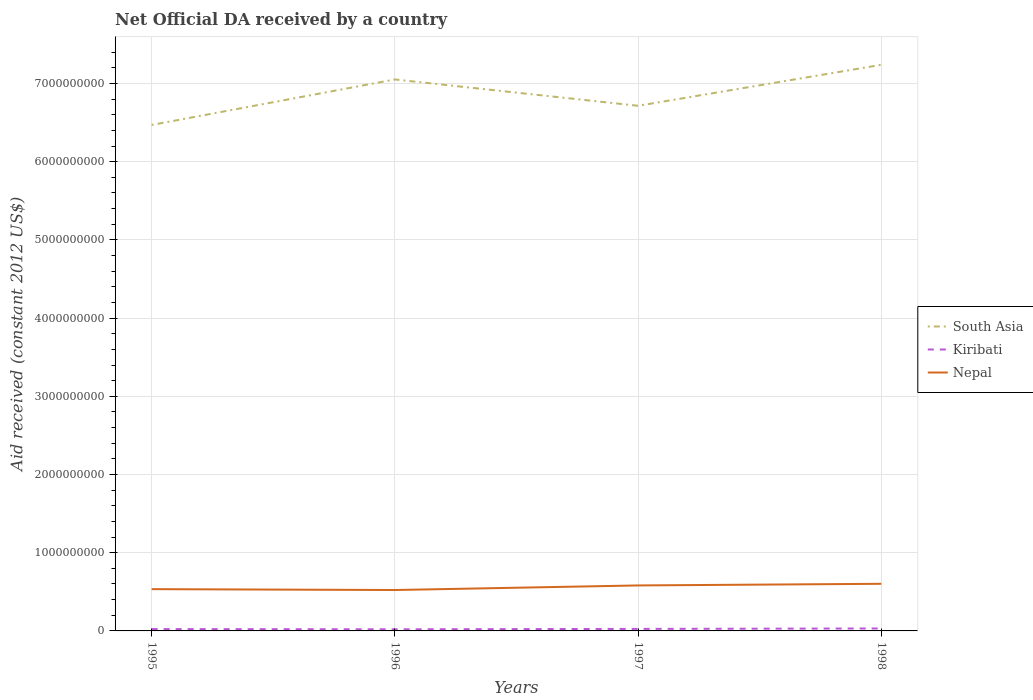How many different coloured lines are there?
Your response must be concise. 3. Does the line corresponding to Kiribati intersect with the line corresponding to South Asia?
Offer a very short reply. No. Is the number of lines equal to the number of legend labels?
Your answer should be compact. Yes. Across all years, what is the maximum net official development assistance aid received in Nepal?
Provide a succinct answer. 5.23e+08. In which year was the net official development assistance aid received in South Asia maximum?
Give a very brief answer. 1995. What is the total net official development assistance aid received in South Asia in the graph?
Your answer should be very brief. -7.69e+08. What is the difference between the highest and the second highest net official development assistance aid received in South Asia?
Offer a very short reply. 7.69e+08. Is the net official development assistance aid received in Kiribati strictly greater than the net official development assistance aid received in South Asia over the years?
Your answer should be very brief. Yes. How many lines are there?
Keep it short and to the point. 3. What is the difference between two consecutive major ticks on the Y-axis?
Make the answer very short. 1.00e+09. Are the values on the major ticks of Y-axis written in scientific E-notation?
Ensure brevity in your answer.  No. Does the graph contain grids?
Provide a succinct answer. Yes. Where does the legend appear in the graph?
Ensure brevity in your answer.  Center right. How many legend labels are there?
Provide a short and direct response. 3. What is the title of the graph?
Your response must be concise. Net Official DA received by a country. Does "Kosovo" appear as one of the legend labels in the graph?
Offer a very short reply. No. What is the label or title of the Y-axis?
Provide a short and direct response. Aid received (constant 2012 US$). What is the Aid received (constant 2012 US$) in South Asia in 1995?
Keep it short and to the point. 6.47e+09. What is the Aid received (constant 2012 US$) of Kiribati in 1995?
Keep it short and to the point. 2.38e+07. What is the Aid received (constant 2012 US$) in Nepal in 1995?
Keep it short and to the point. 5.34e+08. What is the Aid received (constant 2012 US$) of South Asia in 1996?
Your answer should be very brief. 7.05e+09. What is the Aid received (constant 2012 US$) of Kiribati in 1996?
Ensure brevity in your answer.  2.06e+07. What is the Aid received (constant 2012 US$) in Nepal in 1996?
Give a very brief answer. 5.23e+08. What is the Aid received (constant 2012 US$) of South Asia in 1997?
Your answer should be very brief. 6.71e+09. What is the Aid received (constant 2012 US$) of Kiribati in 1997?
Offer a very short reply. 2.59e+07. What is the Aid received (constant 2012 US$) of Nepal in 1997?
Your answer should be compact. 5.82e+08. What is the Aid received (constant 2012 US$) in South Asia in 1998?
Ensure brevity in your answer.  7.24e+09. What is the Aid received (constant 2012 US$) of Kiribati in 1998?
Your answer should be compact. 3.15e+07. What is the Aid received (constant 2012 US$) of Nepal in 1998?
Your answer should be compact. 6.02e+08. Across all years, what is the maximum Aid received (constant 2012 US$) in South Asia?
Provide a succinct answer. 7.24e+09. Across all years, what is the maximum Aid received (constant 2012 US$) of Kiribati?
Your response must be concise. 3.15e+07. Across all years, what is the maximum Aid received (constant 2012 US$) in Nepal?
Give a very brief answer. 6.02e+08. Across all years, what is the minimum Aid received (constant 2012 US$) of South Asia?
Offer a very short reply. 6.47e+09. Across all years, what is the minimum Aid received (constant 2012 US$) of Kiribati?
Your answer should be compact. 2.06e+07. Across all years, what is the minimum Aid received (constant 2012 US$) in Nepal?
Provide a short and direct response. 5.23e+08. What is the total Aid received (constant 2012 US$) of South Asia in the graph?
Offer a very short reply. 2.75e+1. What is the total Aid received (constant 2012 US$) of Kiribati in the graph?
Make the answer very short. 1.02e+08. What is the total Aid received (constant 2012 US$) in Nepal in the graph?
Offer a terse response. 2.24e+09. What is the difference between the Aid received (constant 2012 US$) of South Asia in 1995 and that in 1996?
Keep it short and to the point. -5.82e+08. What is the difference between the Aid received (constant 2012 US$) of Kiribati in 1995 and that in 1996?
Give a very brief answer. 3.16e+06. What is the difference between the Aid received (constant 2012 US$) in Nepal in 1995 and that in 1996?
Give a very brief answer. 1.13e+07. What is the difference between the Aid received (constant 2012 US$) in South Asia in 1995 and that in 1997?
Offer a terse response. -2.45e+08. What is the difference between the Aid received (constant 2012 US$) in Kiribati in 1995 and that in 1997?
Make the answer very short. -2.12e+06. What is the difference between the Aid received (constant 2012 US$) in Nepal in 1995 and that in 1997?
Ensure brevity in your answer.  -4.73e+07. What is the difference between the Aid received (constant 2012 US$) of South Asia in 1995 and that in 1998?
Make the answer very short. -7.69e+08. What is the difference between the Aid received (constant 2012 US$) in Kiribati in 1995 and that in 1998?
Your answer should be very brief. -7.69e+06. What is the difference between the Aid received (constant 2012 US$) in Nepal in 1995 and that in 1998?
Provide a short and direct response. -6.82e+07. What is the difference between the Aid received (constant 2012 US$) in South Asia in 1996 and that in 1997?
Offer a terse response. 3.37e+08. What is the difference between the Aid received (constant 2012 US$) in Kiribati in 1996 and that in 1997?
Your response must be concise. -5.28e+06. What is the difference between the Aid received (constant 2012 US$) of Nepal in 1996 and that in 1997?
Make the answer very short. -5.86e+07. What is the difference between the Aid received (constant 2012 US$) in South Asia in 1996 and that in 1998?
Ensure brevity in your answer.  -1.87e+08. What is the difference between the Aid received (constant 2012 US$) of Kiribati in 1996 and that in 1998?
Your answer should be compact. -1.08e+07. What is the difference between the Aid received (constant 2012 US$) in Nepal in 1996 and that in 1998?
Give a very brief answer. -7.94e+07. What is the difference between the Aid received (constant 2012 US$) of South Asia in 1997 and that in 1998?
Provide a short and direct response. -5.24e+08. What is the difference between the Aid received (constant 2012 US$) in Kiribati in 1997 and that in 1998?
Ensure brevity in your answer.  -5.57e+06. What is the difference between the Aid received (constant 2012 US$) of Nepal in 1997 and that in 1998?
Give a very brief answer. -2.09e+07. What is the difference between the Aid received (constant 2012 US$) of South Asia in 1995 and the Aid received (constant 2012 US$) of Kiribati in 1996?
Offer a terse response. 6.45e+09. What is the difference between the Aid received (constant 2012 US$) in South Asia in 1995 and the Aid received (constant 2012 US$) in Nepal in 1996?
Your answer should be very brief. 5.95e+09. What is the difference between the Aid received (constant 2012 US$) in Kiribati in 1995 and the Aid received (constant 2012 US$) in Nepal in 1996?
Your answer should be very brief. -4.99e+08. What is the difference between the Aid received (constant 2012 US$) of South Asia in 1995 and the Aid received (constant 2012 US$) of Kiribati in 1997?
Offer a very short reply. 6.44e+09. What is the difference between the Aid received (constant 2012 US$) of South Asia in 1995 and the Aid received (constant 2012 US$) of Nepal in 1997?
Your answer should be compact. 5.89e+09. What is the difference between the Aid received (constant 2012 US$) of Kiribati in 1995 and the Aid received (constant 2012 US$) of Nepal in 1997?
Offer a very short reply. -5.58e+08. What is the difference between the Aid received (constant 2012 US$) in South Asia in 1995 and the Aid received (constant 2012 US$) in Kiribati in 1998?
Keep it short and to the point. 6.44e+09. What is the difference between the Aid received (constant 2012 US$) in South Asia in 1995 and the Aid received (constant 2012 US$) in Nepal in 1998?
Your response must be concise. 5.87e+09. What is the difference between the Aid received (constant 2012 US$) in Kiribati in 1995 and the Aid received (constant 2012 US$) in Nepal in 1998?
Ensure brevity in your answer.  -5.79e+08. What is the difference between the Aid received (constant 2012 US$) in South Asia in 1996 and the Aid received (constant 2012 US$) in Kiribati in 1997?
Make the answer very short. 7.03e+09. What is the difference between the Aid received (constant 2012 US$) of South Asia in 1996 and the Aid received (constant 2012 US$) of Nepal in 1997?
Your response must be concise. 6.47e+09. What is the difference between the Aid received (constant 2012 US$) in Kiribati in 1996 and the Aid received (constant 2012 US$) in Nepal in 1997?
Your response must be concise. -5.61e+08. What is the difference between the Aid received (constant 2012 US$) of South Asia in 1996 and the Aid received (constant 2012 US$) of Kiribati in 1998?
Make the answer very short. 7.02e+09. What is the difference between the Aid received (constant 2012 US$) in South Asia in 1996 and the Aid received (constant 2012 US$) in Nepal in 1998?
Your answer should be very brief. 6.45e+09. What is the difference between the Aid received (constant 2012 US$) of Kiribati in 1996 and the Aid received (constant 2012 US$) of Nepal in 1998?
Offer a terse response. -5.82e+08. What is the difference between the Aid received (constant 2012 US$) of South Asia in 1997 and the Aid received (constant 2012 US$) of Kiribati in 1998?
Your answer should be compact. 6.68e+09. What is the difference between the Aid received (constant 2012 US$) in South Asia in 1997 and the Aid received (constant 2012 US$) in Nepal in 1998?
Provide a succinct answer. 6.11e+09. What is the difference between the Aid received (constant 2012 US$) of Kiribati in 1997 and the Aid received (constant 2012 US$) of Nepal in 1998?
Make the answer very short. -5.77e+08. What is the average Aid received (constant 2012 US$) in South Asia per year?
Provide a succinct answer. 6.87e+09. What is the average Aid received (constant 2012 US$) in Kiribati per year?
Offer a terse response. 2.55e+07. What is the average Aid received (constant 2012 US$) in Nepal per year?
Offer a terse response. 5.60e+08. In the year 1995, what is the difference between the Aid received (constant 2012 US$) in South Asia and Aid received (constant 2012 US$) in Kiribati?
Offer a very short reply. 6.45e+09. In the year 1995, what is the difference between the Aid received (constant 2012 US$) in South Asia and Aid received (constant 2012 US$) in Nepal?
Ensure brevity in your answer.  5.94e+09. In the year 1995, what is the difference between the Aid received (constant 2012 US$) in Kiribati and Aid received (constant 2012 US$) in Nepal?
Your answer should be compact. -5.11e+08. In the year 1996, what is the difference between the Aid received (constant 2012 US$) in South Asia and Aid received (constant 2012 US$) in Kiribati?
Ensure brevity in your answer.  7.03e+09. In the year 1996, what is the difference between the Aid received (constant 2012 US$) of South Asia and Aid received (constant 2012 US$) of Nepal?
Ensure brevity in your answer.  6.53e+09. In the year 1996, what is the difference between the Aid received (constant 2012 US$) of Kiribati and Aid received (constant 2012 US$) of Nepal?
Make the answer very short. -5.02e+08. In the year 1997, what is the difference between the Aid received (constant 2012 US$) of South Asia and Aid received (constant 2012 US$) of Kiribati?
Make the answer very short. 6.69e+09. In the year 1997, what is the difference between the Aid received (constant 2012 US$) of South Asia and Aid received (constant 2012 US$) of Nepal?
Provide a succinct answer. 6.13e+09. In the year 1997, what is the difference between the Aid received (constant 2012 US$) in Kiribati and Aid received (constant 2012 US$) in Nepal?
Your response must be concise. -5.56e+08. In the year 1998, what is the difference between the Aid received (constant 2012 US$) of South Asia and Aid received (constant 2012 US$) of Kiribati?
Keep it short and to the point. 7.21e+09. In the year 1998, what is the difference between the Aid received (constant 2012 US$) of South Asia and Aid received (constant 2012 US$) of Nepal?
Your response must be concise. 6.64e+09. In the year 1998, what is the difference between the Aid received (constant 2012 US$) in Kiribati and Aid received (constant 2012 US$) in Nepal?
Your answer should be compact. -5.71e+08. What is the ratio of the Aid received (constant 2012 US$) in South Asia in 1995 to that in 1996?
Make the answer very short. 0.92. What is the ratio of the Aid received (constant 2012 US$) of Kiribati in 1995 to that in 1996?
Offer a very short reply. 1.15. What is the ratio of the Aid received (constant 2012 US$) of Nepal in 1995 to that in 1996?
Provide a short and direct response. 1.02. What is the ratio of the Aid received (constant 2012 US$) in South Asia in 1995 to that in 1997?
Provide a short and direct response. 0.96. What is the ratio of the Aid received (constant 2012 US$) of Kiribati in 1995 to that in 1997?
Keep it short and to the point. 0.92. What is the ratio of the Aid received (constant 2012 US$) in Nepal in 1995 to that in 1997?
Give a very brief answer. 0.92. What is the ratio of the Aid received (constant 2012 US$) in South Asia in 1995 to that in 1998?
Ensure brevity in your answer.  0.89. What is the ratio of the Aid received (constant 2012 US$) in Kiribati in 1995 to that in 1998?
Ensure brevity in your answer.  0.76. What is the ratio of the Aid received (constant 2012 US$) in Nepal in 1995 to that in 1998?
Offer a terse response. 0.89. What is the ratio of the Aid received (constant 2012 US$) in South Asia in 1996 to that in 1997?
Keep it short and to the point. 1.05. What is the ratio of the Aid received (constant 2012 US$) of Kiribati in 1996 to that in 1997?
Your answer should be very brief. 0.8. What is the ratio of the Aid received (constant 2012 US$) of Nepal in 1996 to that in 1997?
Provide a short and direct response. 0.9. What is the ratio of the Aid received (constant 2012 US$) of South Asia in 1996 to that in 1998?
Keep it short and to the point. 0.97. What is the ratio of the Aid received (constant 2012 US$) of Kiribati in 1996 to that in 1998?
Provide a short and direct response. 0.66. What is the ratio of the Aid received (constant 2012 US$) of Nepal in 1996 to that in 1998?
Provide a succinct answer. 0.87. What is the ratio of the Aid received (constant 2012 US$) of South Asia in 1997 to that in 1998?
Your answer should be very brief. 0.93. What is the ratio of the Aid received (constant 2012 US$) in Kiribati in 1997 to that in 1998?
Give a very brief answer. 0.82. What is the ratio of the Aid received (constant 2012 US$) in Nepal in 1997 to that in 1998?
Keep it short and to the point. 0.97. What is the difference between the highest and the second highest Aid received (constant 2012 US$) of South Asia?
Your response must be concise. 1.87e+08. What is the difference between the highest and the second highest Aid received (constant 2012 US$) of Kiribati?
Keep it short and to the point. 5.57e+06. What is the difference between the highest and the second highest Aid received (constant 2012 US$) of Nepal?
Your answer should be very brief. 2.09e+07. What is the difference between the highest and the lowest Aid received (constant 2012 US$) in South Asia?
Your answer should be very brief. 7.69e+08. What is the difference between the highest and the lowest Aid received (constant 2012 US$) of Kiribati?
Offer a very short reply. 1.08e+07. What is the difference between the highest and the lowest Aid received (constant 2012 US$) of Nepal?
Make the answer very short. 7.94e+07. 